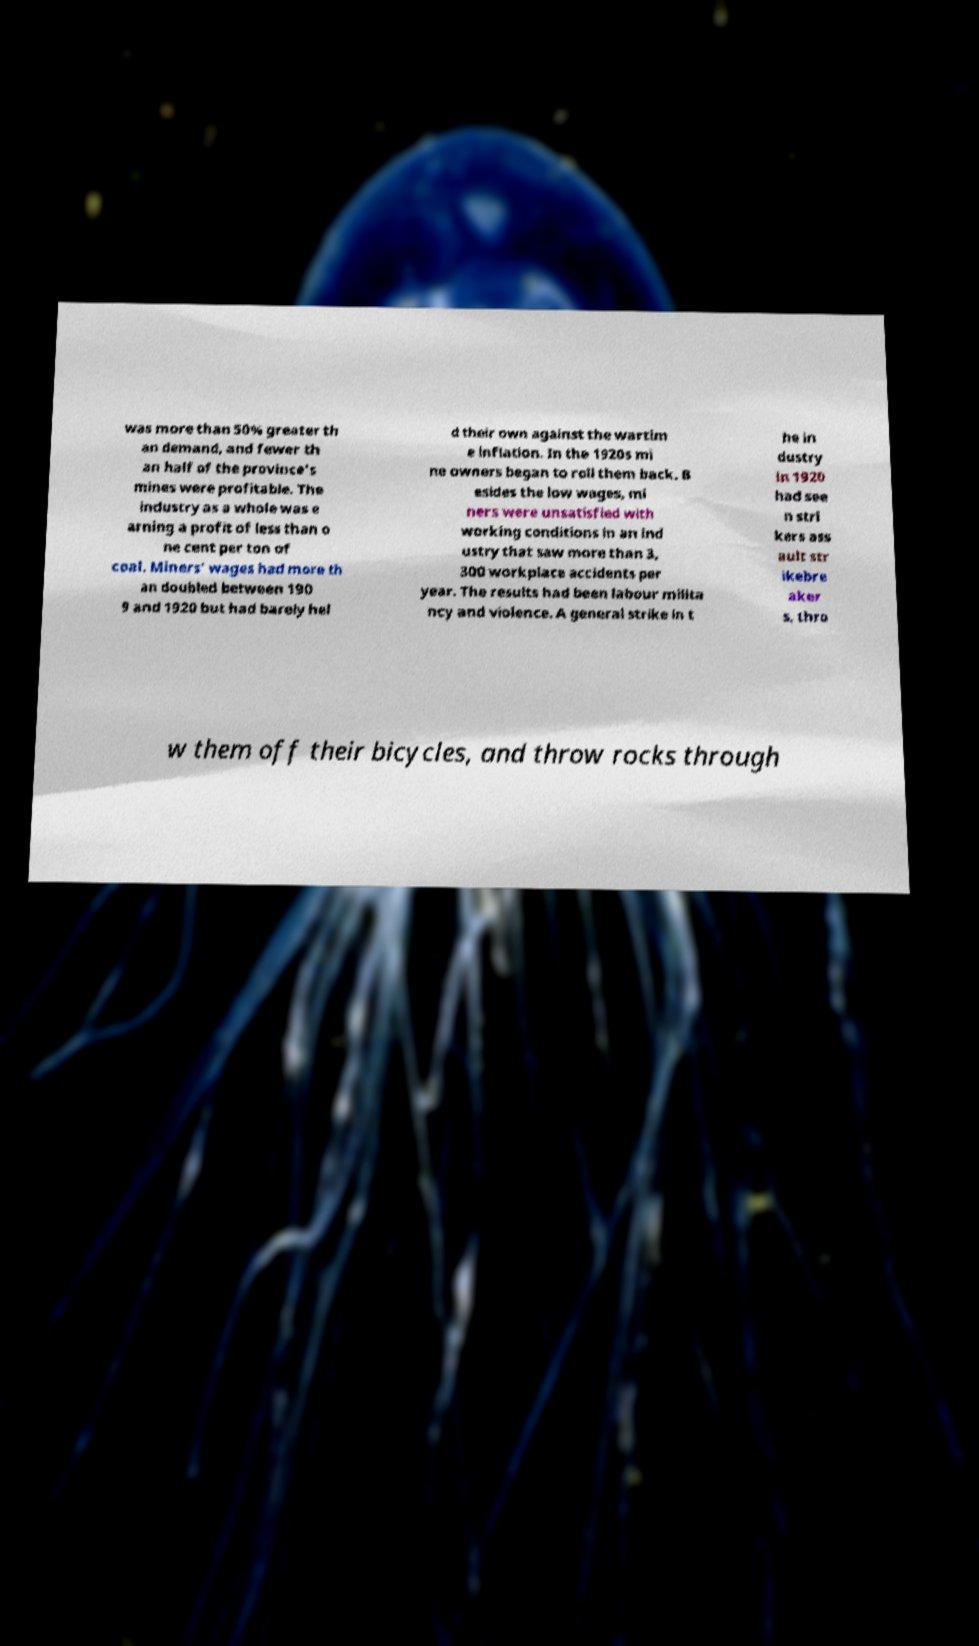Could you extract and type out the text from this image? was more than 50% greater th an demand, and fewer th an half of the province's mines were profitable. The industry as a whole was e arning a profit of less than o ne cent per ton of coal. Miners' wages had more th an doubled between 190 9 and 1920 but had barely hel d their own against the wartim e inflation. In the 1920s mi ne owners began to roll them back. B esides the low wages, mi ners were unsatisfied with working conditions in an ind ustry that saw more than 3, 300 workplace accidents per year. The results had been labour milita ncy and violence. A general strike in t he in dustry in 1920 had see n stri kers ass ault str ikebre aker s, thro w them off their bicycles, and throw rocks through 